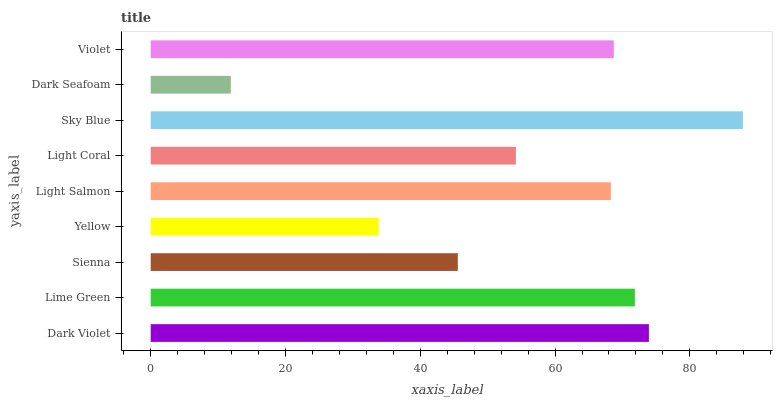Is Dark Seafoam the minimum?
Answer yes or no. Yes. Is Sky Blue the maximum?
Answer yes or no. Yes. Is Lime Green the minimum?
Answer yes or no. No. Is Lime Green the maximum?
Answer yes or no. No. Is Dark Violet greater than Lime Green?
Answer yes or no. Yes. Is Lime Green less than Dark Violet?
Answer yes or no. Yes. Is Lime Green greater than Dark Violet?
Answer yes or no. No. Is Dark Violet less than Lime Green?
Answer yes or no. No. Is Light Salmon the high median?
Answer yes or no. Yes. Is Light Salmon the low median?
Answer yes or no. Yes. Is Sienna the high median?
Answer yes or no. No. Is Violet the low median?
Answer yes or no. No. 